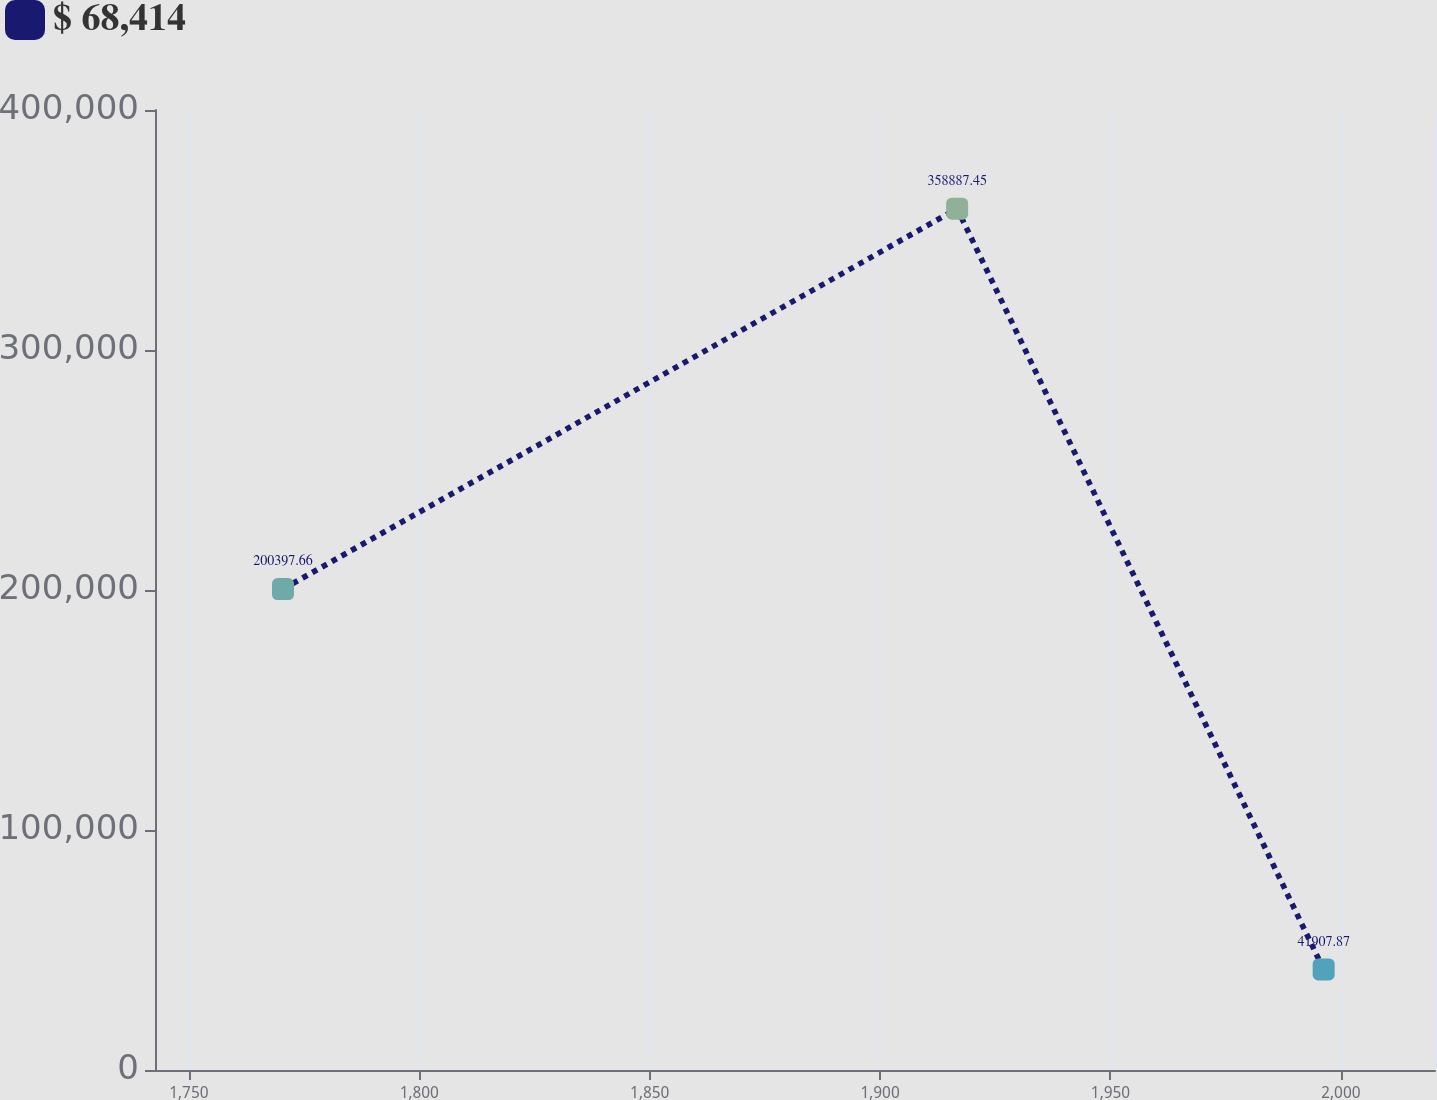Convert chart to OTSL. <chart><loc_0><loc_0><loc_500><loc_500><line_chart><ecel><fcel>$ 68,414<nl><fcel>1770.42<fcel>200398<nl><fcel>1916.72<fcel>358887<nl><fcel>1996.26<fcel>41907.9<nl><fcel>2048.2<fcel>1.62681e+06<nl></chart> 